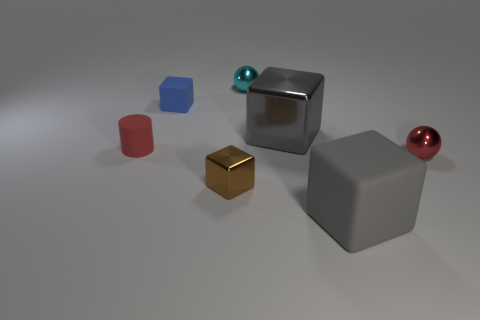There is a red object right of the blue block; what is its material?
Keep it short and to the point. Metal. Is the big gray metallic thing the same shape as the tiny blue thing?
Your answer should be very brief. Yes. There is a sphere on the left side of the matte object that is in front of the tiny metal sphere that is in front of the cyan ball; what color is it?
Offer a terse response. Cyan. What number of tiny blue rubber things have the same shape as the small brown shiny object?
Your response must be concise. 1. How big is the matte block that is in front of the red thing in front of the red matte cylinder?
Offer a terse response. Large. Do the cyan sphere and the gray rubber block have the same size?
Your response must be concise. No. There is a metallic ball to the left of the large cube in front of the large metal thing; are there any cyan objects that are on the left side of it?
Ensure brevity in your answer.  No. What is the size of the red metal thing?
Your answer should be very brief. Small. How many gray rubber cubes are the same size as the brown object?
Your answer should be compact. 0. What is the material of the red thing that is the same shape as the cyan shiny thing?
Your answer should be very brief. Metal. 